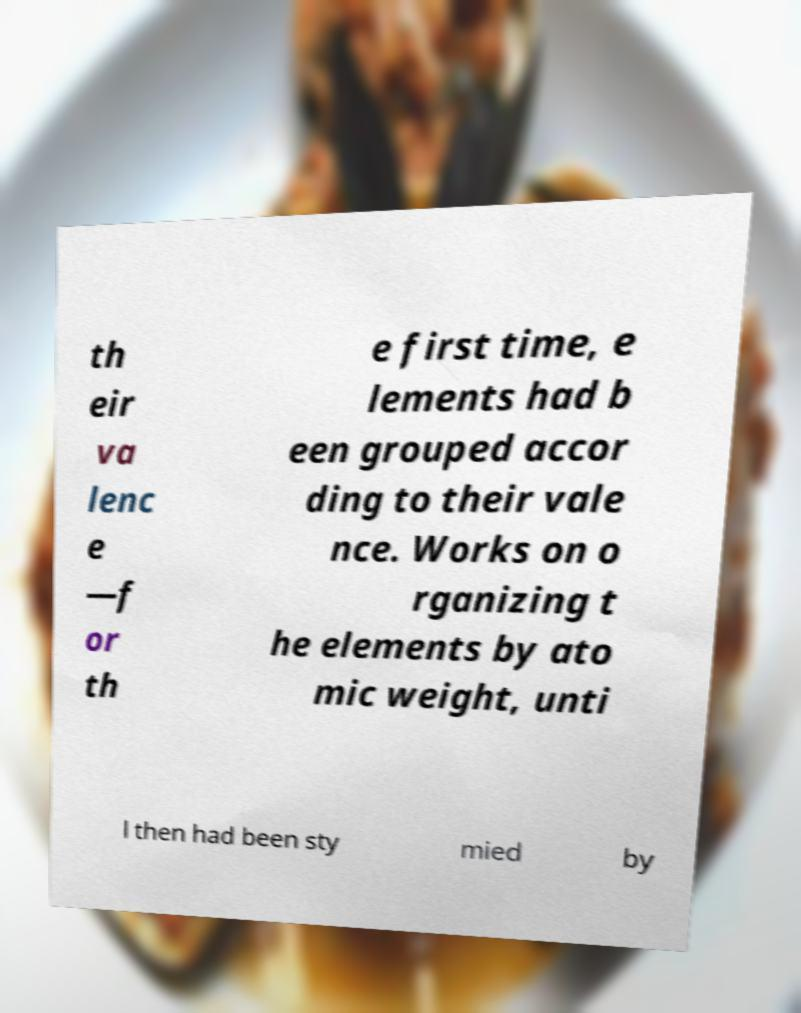Can you read and provide the text displayed in the image?This photo seems to have some interesting text. Can you extract and type it out for me? th eir va lenc e —f or th e first time, e lements had b een grouped accor ding to their vale nce. Works on o rganizing t he elements by ato mic weight, unti l then had been sty mied by 